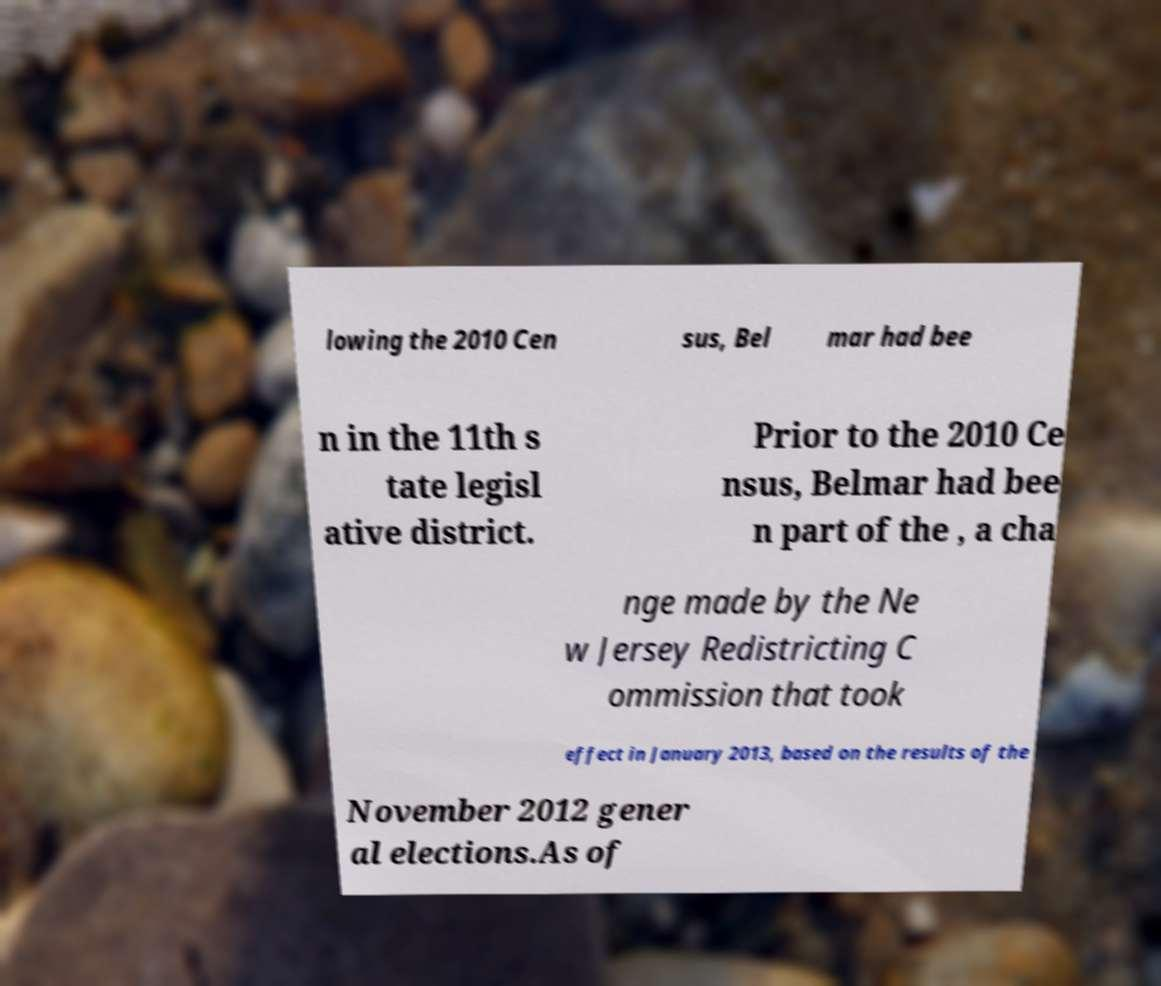Please read and relay the text visible in this image. What does it say? lowing the 2010 Cen sus, Bel mar had bee n in the 11th s tate legisl ative district. Prior to the 2010 Ce nsus, Belmar had bee n part of the , a cha nge made by the Ne w Jersey Redistricting C ommission that took effect in January 2013, based on the results of the November 2012 gener al elections.As of 